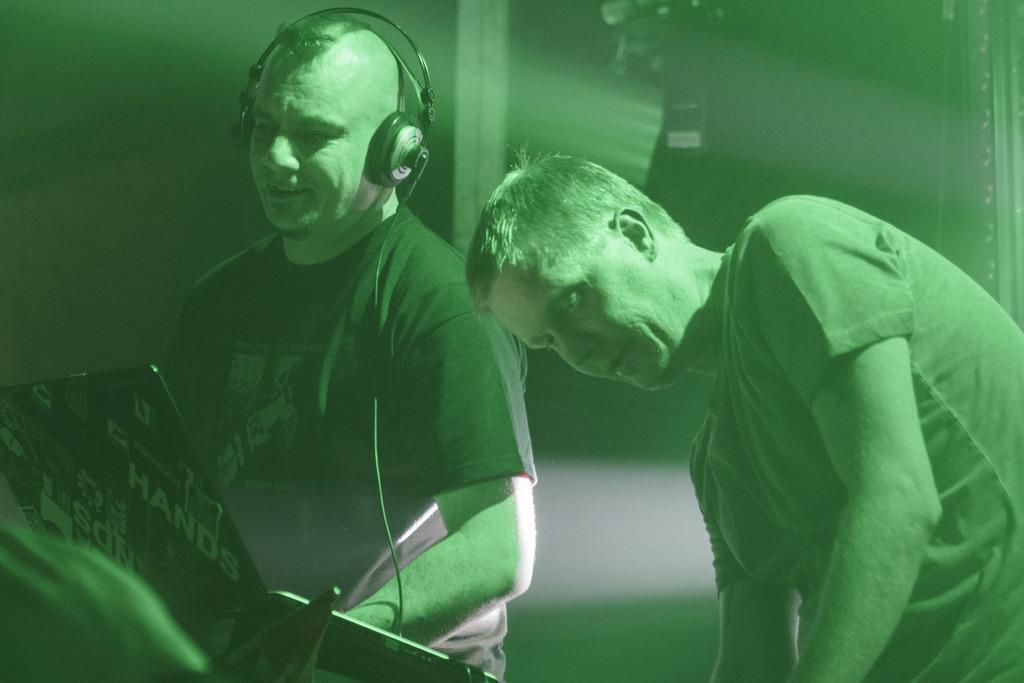Please provide a concise description of this image. In this picture we can see two people. This person wore a headset. These people are looking at these boards. Background it is blur. 